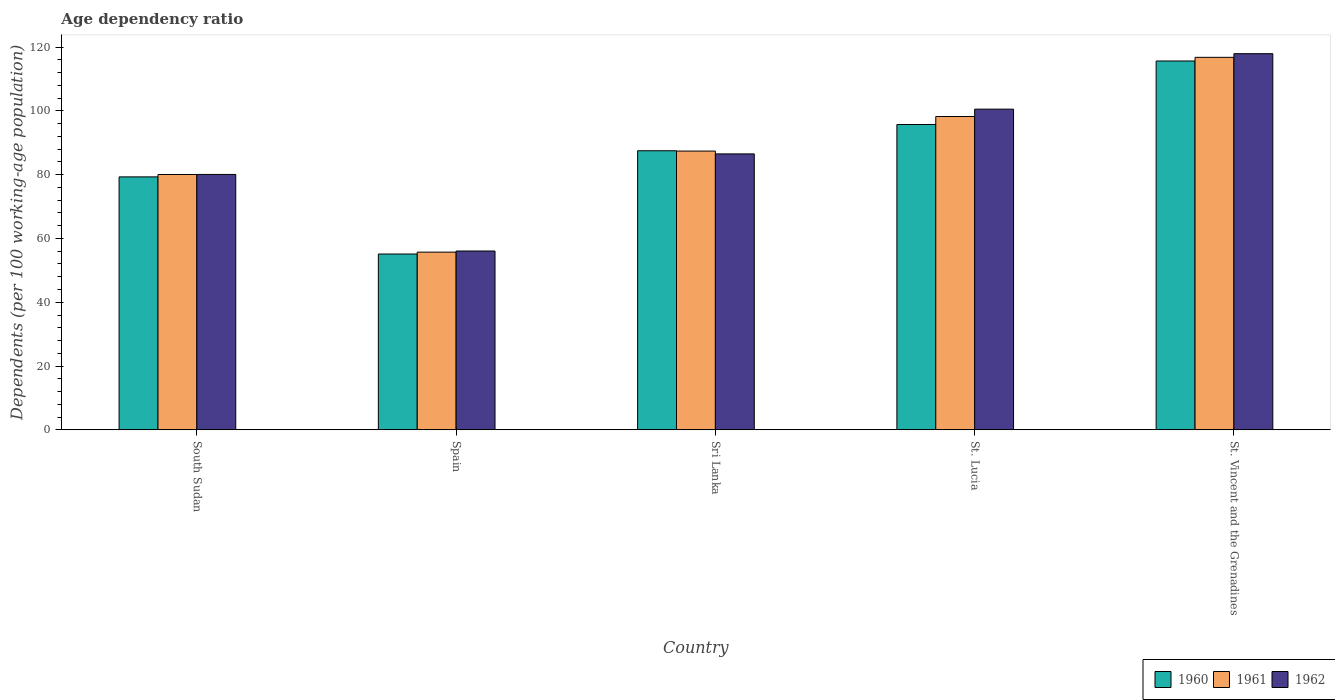How many groups of bars are there?
Keep it short and to the point. 5. Are the number of bars per tick equal to the number of legend labels?
Offer a terse response. Yes. Are the number of bars on each tick of the X-axis equal?
Make the answer very short. Yes. How many bars are there on the 4th tick from the left?
Provide a succinct answer. 3. What is the label of the 4th group of bars from the left?
Keep it short and to the point. St. Lucia. In how many cases, is the number of bars for a given country not equal to the number of legend labels?
Provide a succinct answer. 0. What is the age dependency ratio in in 1960 in St. Vincent and the Grenadines?
Your answer should be compact. 115.67. Across all countries, what is the maximum age dependency ratio in in 1961?
Your response must be concise. 116.81. Across all countries, what is the minimum age dependency ratio in in 1962?
Your answer should be compact. 56.08. In which country was the age dependency ratio in in 1960 maximum?
Offer a terse response. St. Vincent and the Grenadines. What is the total age dependency ratio in in 1962 in the graph?
Offer a very short reply. 441.21. What is the difference between the age dependency ratio in in 1960 in Sri Lanka and that in St. Lucia?
Offer a very short reply. -8.23. What is the difference between the age dependency ratio in in 1962 in South Sudan and the age dependency ratio in in 1961 in St. Vincent and the Grenadines?
Give a very brief answer. -36.73. What is the average age dependency ratio in in 1960 per country?
Keep it short and to the point. 86.68. What is the difference between the age dependency ratio in of/in 1962 and age dependency ratio in of/in 1961 in South Sudan?
Your answer should be very brief. 0.02. In how many countries, is the age dependency ratio in in 1962 greater than 112 %?
Offer a terse response. 1. What is the ratio of the age dependency ratio in in 1962 in Spain to that in Sri Lanka?
Your answer should be compact. 0.65. Is the age dependency ratio in in 1961 in Sri Lanka less than that in St. Lucia?
Keep it short and to the point. Yes. What is the difference between the highest and the second highest age dependency ratio in in 1960?
Your answer should be very brief. 28.15. What is the difference between the highest and the lowest age dependency ratio in in 1962?
Make the answer very short. 61.88. In how many countries, is the age dependency ratio in in 1962 greater than the average age dependency ratio in in 1962 taken over all countries?
Your response must be concise. 2. Is it the case that in every country, the sum of the age dependency ratio in in 1962 and age dependency ratio in in 1961 is greater than the age dependency ratio in in 1960?
Your answer should be very brief. Yes. How many countries are there in the graph?
Your answer should be compact. 5. Does the graph contain any zero values?
Provide a short and direct response. No. Does the graph contain grids?
Give a very brief answer. No. Where does the legend appear in the graph?
Your answer should be compact. Bottom right. What is the title of the graph?
Keep it short and to the point. Age dependency ratio. What is the label or title of the Y-axis?
Provide a succinct answer. Dependents (per 100 working-age population). What is the Dependents (per 100 working-age population) in 1960 in South Sudan?
Provide a short and direct response. 79.32. What is the Dependents (per 100 working-age population) of 1961 in South Sudan?
Your response must be concise. 80.07. What is the Dependents (per 100 working-age population) in 1962 in South Sudan?
Your response must be concise. 80.09. What is the Dependents (per 100 working-age population) of 1960 in Spain?
Give a very brief answer. 55.13. What is the Dependents (per 100 working-age population) of 1961 in Spain?
Offer a terse response. 55.72. What is the Dependents (per 100 working-age population) of 1962 in Spain?
Your answer should be very brief. 56.08. What is the Dependents (per 100 working-age population) in 1960 in Sri Lanka?
Give a very brief answer. 87.51. What is the Dependents (per 100 working-age population) in 1961 in Sri Lanka?
Provide a succinct answer. 87.42. What is the Dependents (per 100 working-age population) of 1962 in Sri Lanka?
Provide a short and direct response. 86.53. What is the Dependents (per 100 working-age population) in 1960 in St. Lucia?
Provide a short and direct response. 95.75. What is the Dependents (per 100 working-age population) of 1961 in St. Lucia?
Your response must be concise. 98.26. What is the Dependents (per 100 working-age population) of 1962 in St. Lucia?
Your answer should be very brief. 100.56. What is the Dependents (per 100 working-age population) of 1960 in St. Vincent and the Grenadines?
Provide a succinct answer. 115.67. What is the Dependents (per 100 working-age population) in 1961 in St. Vincent and the Grenadines?
Offer a terse response. 116.81. What is the Dependents (per 100 working-age population) of 1962 in St. Vincent and the Grenadines?
Give a very brief answer. 117.96. Across all countries, what is the maximum Dependents (per 100 working-age population) in 1960?
Give a very brief answer. 115.67. Across all countries, what is the maximum Dependents (per 100 working-age population) in 1961?
Your response must be concise. 116.81. Across all countries, what is the maximum Dependents (per 100 working-age population) of 1962?
Ensure brevity in your answer.  117.96. Across all countries, what is the minimum Dependents (per 100 working-age population) of 1960?
Your answer should be very brief. 55.13. Across all countries, what is the minimum Dependents (per 100 working-age population) of 1961?
Give a very brief answer. 55.72. Across all countries, what is the minimum Dependents (per 100 working-age population) of 1962?
Provide a short and direct response. 56.08. What is the total Dependents (per 100 working-age population) in 1960 in the graph?
Provide a succinct answer. 433.38. What is the total Dependents (per 100 working-age population) in 1961 in the graph?
Offer a very short reply. 438.28. What is the total Dependents (per 100 working-age population) in 1962 in the graph?
Your response must be concise. 441.21. What is the difference between the Dependents (per 100 working-age population) of 1960 in South Sudan and that in Spain?
Offer a terse response. 24.19. What is the difference between the Dependents (per 100 working-age population) in 1961 in South Sudan and that in Spain?
Offer a very short reply. 24.34. What is the difference between the Dependents (per 100 working-age population) of 1962 in South Sudan and that in Spain?
Keep it short and to the point. 24.01. What is the difference between the Dependents (per 100 working-age population) of 1960 in South Sudan and that in Sri Lanka?
Provide a short and direct response. -8.19. What is the difference between the Dependents (per 100 working-age population) in 1961 in South Sudan and that in Sri Lanka?
Provide a succinct answer. -7.35. What is the difference between the Dependents (per 100 working-age population) in 1962 in South Sudan and that in Sri Lanka?
Ensure brevity in your answer.  -6.44. What is the difference between the Dependents (per 100 working-age population) in 1960 in South Sudan and that in St. Lucia?
Your answer should be very brief. -16.42. What is the difference between the Dependents (per 100 working-age population) of 1961 in South Sudan and that in St. Lucia?
Provide a short and direct response. -18.19. What is the difference between the Dependents (per 100 working-age population) in 1962 in South Sudan and that in St. Lucia?
Your answer should be very brief. -20.47. What is the difference between the Dependents (per 100 working-age population) in 1960 in South Sudan and that in St. Vincent and the Grenadines?
Ensure brevity in your answer.  -36.34. What is the difference between the Dependents (per 100 working-age population) in 1961 in South Sudan and that in St. Vincent and the Grenadines?
Offer a very short reply. -36.75. What is the difference between the Dependents (per 100 working-age population) in 1962 in South Sudan and that in St. Vincent and the Grenadines?
Offer a terse response. -37.87. What is the difference between the Dependents (per 100 working-age population) in 1960 in Spain and that in Sri Lanka?
Ensure brevity in your answer.  -32.38. What is the difference between the Dependents (per 100 working-age population) in 1961 in Spain and that in Sri Lanka?
Your answer should be compact. -31.7. What is the difference between the Dependents (per 100 working-age population) in 1962 in Spain and that in Sri Lanka?
Offer a terse response. -30.45. What is the difference between the Dependents (per 100 working-age population) in 1960 in Spain and that in St. Lucia?
Provide a short and direct response. -40.62. What is the difference between the Dependents (per 100 working-age population) in 1961 in Spain and that in St. Lucia?
Offer a very short reply. -42.54. What is the difference between the Dependents (per 100 working-age population) of 1962 in Spain and that in St. Lucia?
Your response must be concise. -44.49. What is the difference between the Dependents (per 100 working-age population) of 1960 in Spain and that in St. Vincent and the Grenadines?
Keep it short and to the point. -60.53. What is the difference between the Dependents (per 100 working-age population) of 1961 in Spain and that in St. Vincent and the Grenadines?
Your response must be concise. -61.09. What is the difference between the Dependents (per 100 working-age population) in 1962 in Spain and that in St. Vincent and the Grenadines?
Offer a very short reply. -61.88. What is the difference between the Dependents (per 100 working-age population) in 1960 in Sri Lanka and that in St. Lucia?
Your response must be concise. -8.23. What is the difference between the Dependents (per 100 working-age population) in 1961 in Sri Lanka and that in St. Lucia?
Your response must be concise. -10.84. What is the difference between the Dependents (per 100 working-age population) in 1962 in Sri Lanka and that in St. Lucia?
Your answer should be compact. -14.03. What is the difference between the Dependents (per 100 working-age population) of 1960 in Sri Lanka and that in St. Vincent and the Grenadines?
Your answer should be very brief. -28.15. What is the difference between the Dependents (per 100 working-age population) of 1961 in Sri Lanka and that in St. Vincent and the Grenadines?
Ensure brevity in your answer.  -29.39. What is the difference between the Dependents (per 100 working-age population) of 1962 in Sri Lanka and that in St. Vincent and the Grenadines?
Make the answer very short. -31.43. What is the difference between the Dependents (per 100 working-age population) in 1960 in St. Lucia and that in St. Vincent and the Grenadines?
Provide a succinct answer. -19.92. What is the difference between the Dependents (per 100 working-age population) of 1961 in St. Lucia and that in St. Vincent and the Grenadines?
Offer a very short reply. -18.56. What is the difference between the Dependents (per 100 working-age population) in 1962 in St. Lucia and that in St. Vincent and the Grenadines?
Your response must be concise. -17.4. What is the difference between the Dependents (per 100 working-age population) in 1960 in South Sudan and the Dependents (per 100 working-age population) in 1961 in Spain?
Offer a very short reply. 23.6. What is the difference between the Dependents (per 100 working-age population) in 1960 in South Sudan and the Dependents (per 100 working-age population) in 1962 in Spain?
Your answer should be compact. 23.25. What is the difference between the Dependents (per 100 working-age population) in 1961 in South Sudan and the Dependents (per 100 working-age population) in 1962 in Spain?
Provide a short and direct response. 23.99. What is the difference between the Dependents (per 100 working-age population) of 1960 in South Sudan and the Dependents (per 100 working-age population) of 1961 in Sri Lanka?
Make the answer very short. -8.1. What is the difference between the Dependents (per 100 working-age population) in 1960 in South Sudan and the Dependents (per 100 working-age population) in 1962 in Sri Lanka?
Offer a very short reply. -7.21. What is the difference between the Dependents (per 100 working-age population) in 1961 in South Sudan and the Dependents (per 100 working-age population) in 1962 in Sri Lanka?
Provide a succinct answer. -6.46. What is the difference between the Dependents (per 100 working-age population) of 1960 in South Sudan and the Dependents (per 100 working-age population) of 1961 in St. Lucia?
Keep it short and to the point. -18.93. What is the difference between the Dependents (per 100 working-age population) in 1960 in South Sudan and the Dependents (per 100 working-age population) in 1962 in St. Lucia?
Offer a terse response. -21.24. What is the difference between the Dependents (per 100 working-age population) in 1961 in South Sudan and the Dependents (per 100 working-age population) in 1962 in St. Lucia?
Give a very brief answer. -20.5. What is the difference between the Dependents (per 100 working-age population) in 1960 in South Sudan and the Dependents (per 100 working-age population) in 1961 in St. Vincent and the Grenadines?
Ensure brevity in your answer.  -37.49. What is the difference between the Dependents (per 100 working-age population) in 1960 in South Sudan and the Dependents (per 100 working-age population) in 1962 in St. Vincent and the Grenadines?
Make the answer very short. -38.64. What is the difference between the Dependents (per 100 working-age population) in 1961 in South Sudan and the Dependents (per 100 working-age population) in 1962 in St. Vincent and the Grenadines?
Your response must be concise. -37.89. What is the difference between the Dependents (per 100 working-age population) of 1960 in Spain and the Dependents (per 100 working-age population) of 1961 in Sri Lanka?
Give a very brief answer. -32.29. What is the difference between the Dependents (per 100 working-age population) in 1960 in Spain and the Dependents (per 100 working-age population) in 1962 in Sri Lanka?
Ensure brevity in your answer.  -31.4. What is the difference between the Dependents (per 100 working-age population) of 1961 in Spain and the Dependents (per 100 working-age population) of 1962 in Sri Lanka?
Provide a succinct answer. -30.81. What is the difference between the Dependents (per 100 working-age population) in 1960 in Spain and the Dependents (per 100 working-age population) in 1961 in St. Lucia?
Give a very brief answer. -43.13. What is the difference between the Dependents (per 100 working-age population) in 1960 in Spain and the Dependents (per 100 working-age population) in 1962 in St. Lucia?
Your answer should be compact. -45.43. What is the difference between the Dependents (per 100 working-age population) in 1961 in Spain and the Dependents (per 100 working-age population) in 1962 in St. Lucia?
Offer a very short reply. -44.84. What is the difference between the Dependents (per 100 working-age population) in 1960 in Spain and the Dependents (per 100 working-age population) in 1961 in St. Vincent and the Grenadines?
Give a very brief answer. -61.68. What is the difference between the Dependents (per 100 working-age population) of 1960 in Spain and the Dependents (per 100 working-age population) of 1962 in St. Vincent and the Grenadines?
Keep it short and to the point. -62.83. What is the difference between the Dependents (per 100 working-age population) in 1961 in Spain and the Dependents (per 100 working-age population) in 1962 in St. Vincent and the Grenadines?
Make the answer very short. -62.24. What is the difference between the Dependents (per 100 working-age population) in 1960 in Sri Lanka and the Dependents (per 100 working-age population) in 1961 in St. Lucia?
Your answer should be compact. -10.74. What is the difference between the Dependents (per 100 working-age population) in 1960 in Sri Lanka and the Dependents (per 100 working-age population) in 1962 in St. Lucia?
Provide a succinct answer. -13.05. What is the difference between the Dependents (per 100 working-age population) in 1961 in Sri Lanka and the Dependents (per 100 working-age population) in 1962 in St. Lucia?
Offer a very short reply. -13.14. What is the difference between the Dependents (per 100 working-age population) in 1960 in Sri Lanka and the Dependents (per 100 working-age population) in 1961 in St. Vincent and the Grenadines?
Provide a succinct answer. -29.3. What is the difference between the Dependents (per 100 working-age population) of 1960 in Sri Lanka and the Dependents (per 100 working-age population) of 1962 in St. Vincent and the Grenadines?
Offer a very short reply. -30.45. What is the difference between the Dependents (per 100 working-age population) of 1961 in Sri Lanka and the Dependents (per 100 working-age population) of 1962 in St. Vincent and the Grenadines?
Provide a short and direct response. -30.54. What is the difference between the Dependents (per 100 working-age population) of 1960 in St. Lucia and the Dependents (per 100 working-age population) of 1961 in St. Vincent and the Grenadines?
Offer a very short reply. -21.07. What is the difference between the Dependents (per 100 working-age population) in 1960 in St. Lucia and the Dependents (per 100 working-age population) in 1962 in St. Vincent and the Grenadines?
Your answer should be compact. -22.21. What is the difference between the Dependents (per 100 working-age population) in 1961 in St. Lucia and the Dependents (per 100 working-age population) in 1962 in St. Vincent and the Grenadines?
Give a very brief answer. -19.7. What is the average Dependents (per 100 working-age population) of 1960 per country?
Ensure brevity in your answer.  86.68. What is the average Dependents (per 100 working-age population) in 1961 per country?
Keep it short and to the point. 87.66. What is the average Dependents (per 100 working-age population) in 1962 per country?
Your response must be concise. 88.24. What is the difference between the Dependents (per 100 working-age population) of 1960 and Dependents (per 100 working-age population) of 1961 in South Sudan?
Your response must be concise. -0.74. What is the difference between the Dependents (per 100 working-age population) of 1960 and Dependents (per 100 working-age population) of 1962 in South Sudan?
Ensure brevity in your answer.  -0.76. What is the difference between the Dependents (per 100 working-age population) of 1961 and Dependents (per 100 working-age population) of 1962 in South Sudan?
Give a very brief answer. -0.02. What is the difference between the Dependents (per 100 working-age population) of 1960 and Dependents (per 100 working-age population) of 1961 in Spain?
Offer a terse response. -0.59. What is the difference between the Dependents (per 100 working-age population) in 1960 and Dependents (per 100 working-age population) in 1962 in Spain?
Give a very brief answer. -0.94. What is the difference between the Dependents (per 100 working-age population) in 1961 and Dependents (per 100 working-age population) in 1962 in Spain?
Give a very brief answer. -0.35. What is the difference between the Dependents (per 100 working-age population) in 1960 and Dependents (per 100 working-age population) in 1961 in Sri Lanka?
Offer a very short reply. 0.09. What is the difference between the Dependents (per 100 working-age population) of 1960 and Dependents (per 100 working-age population) of 1962 in Sri Lanka?
Keep it short and to the point. 0.98. What is the difference between the Dependents (per 100 working-age population) of 1961 and Dependents (per 100 working-age population) of 1962 in Sri Lanka?
Provide a short and direct response. 0.89. What is the difference between the Dependents (per 100 working-age population) in 1960 and Dependents (per 100 working-age population) in 1961 in St. Lucia?
Give a very brief answer. -2.51. What is the difference between the Dependents (per 100 working-age population) in 1960 and Dependents (per 100 working-age population) in 1962 in St. Lucia?
Your answer should be very brief. -4.81. What is the difference between the Dependents (per 100 working-age population) of 1961 and Dependents (per 100 working-age population) of 1962 in St. Lucia?
Give a very brief answer. -2.3. What is the difference between the Dependents (per 100 working-age population) in 1960 and Dependents (per 100 working-age population) in 1961 in St. Vincent and the Grenadines?
Your response must be concise. -1.15. What is the difference between the Dependents (per 100 working-age population) in 1960 and Dependents (per 100 working-age population) in 1962 in St. Vincent and the Grenadines?
Provide a succinct answer. -2.29. What is the difference between the Dependents (per 100 working-age population) of 1961 and Dependents (per 100 working-age population) of 1962 in St. Vincent and the Grenadines?
Keep it short and to the point. -1.15. What is the ratio of the Dependents (per 100 working-age population) of 1960 in South Sudan to that in Spain?
Offer a very short reply. 1.44. What is the ratio of the Dependents (per 100 working-age population) in 1961 in South Sudan to that in Spain?
Offer a very short reply. 1.44. What is the ratio of the Dependents (per 100 working-age population) in 1962 in South Sudan to that in Spain?
Your response must be concise. 1.43. What is the ratio of the Dependents (per 100 working-age population) of 1960 in South Sudan to that in Sri Lanka?
Offer a very short reply. 0.91. What is the ratio of the Dependents (per 100 working-age population) of 1961 in South Sudan to that in Sri Lanka?
Make the answer very short. 0.92. What is the ratio of the Dependents (per 100 working-age population) in 1962 in South Sudan to that in Sri Lanka?
Keep it short and to the point. 0.93. What is the ratio of the Dependents (per 100 working-age population) of 1960 in South Sudan to that in St. Lucia?
Ensure brevity in your answer.  0.83. What is the ratio of the Dependents (per 100 working-age population) of 1961 in South Sudan to that in St. Lucia?
Offer a terse response. 0.81. What is the ratio of the Dependents (per 100 working-age population) in 1962 in South Sudan to that in St. Lucia?
Give a very brief answer. 0.8. What is the ratio of the Dependents (per 100 working-age population) in 1960 in South Sudan to that in St. Vincent and the Grenadines?
Your response must be concise. 0.69. What is the ratio of the Dependents (per 100 working-age population) in 1961 in South Sudan to that in St. Vincent and the Grenadines?
Keep it short and to the point. 0.69. What is the ratio of the Dependents (per 100 working-age population) in 1962 in South Sudan to that in St. Vincent and the Grenadines?
Your answer should be very brief. 0.68. What is the ratio of the Dependents (per 100 working-age population) in 1960 in Spain to that in Sri Lanka?
Offer a very short reply. 0.63. What is the ratio of the Dependents (per 100 working-age population) of 1961 in Spain to that in Sri Lanka?
Offer a terse response. 0.64. What is the ratio of the Dependents (per 100 working-age population) of 1962 in Spain to that in Sri Lanka?
Keep it short and to the point. 0.65. What is the ratio of the Dependents (per 100 working-age population) in 1960 in Spain to that in St. Lucia?
Give a very brief answer. 0.58. What is the ratio of the Dependents (per 100 working-age population) of 1961 in Spain to that in St. Lucia?
Make the answer very short. 0.57. What is the ratio of the Dependents (per 100 working-age population) of 1962 in Spain to that in St. Lucia?
Keep it short and to the point. 0.56. What is the ratio of the Dependents (per 100 working-age population) of 1960 in Spain to that in St. Vincent and the Grenadines?
Your answer should be very brief. 0.48. What is the ratio of the Dependents (per 100 working-age population) of 1961 in Spain to that in St. Vincent and the Grenadines?
Give a very brief answer. 0.48. What is the ratio of the Dependents (per 100 working-age population) in 1962 in Spain to that in St. Vincent and the Grenadines?
Your answer should be very brief. 0.48. What is the ratio of the Dependents (per 100 working-age population) of 1960 in Sri Lanka to that in St. Lucia?
Your answer should be compact. 0.91. What is the ratio of the Dependents (per 100 working-age population) in 1961 in Sri Lanka to that in St. Lucia?
Offer a terse response. 0.89. What is the ratio of the Dependents (per 100 working-age population) of 1962 in Sri Lanka to that in St. Lucia?
Your answer should be very brief. 0.86. What is the ratio of the Dependents (per 100 working-age population) in 1960 in Sri Lanka to that in St. Vincent and the Grenadines?
Keep it short and to the point. 0.76. What is the ratio of the Dependents (per 100 working-age population) in 1961 in Sri Lanka to that in St. Vincent and the Grenadines?
Your response must be concise. 0.75. What is the ratio of the Dependents (per 100 working-age population) of 1962 in Sri Lanka to that in St. Vincent and the Grenadines?
Your answer should be compact. 0.73. What is the ratio of the Dependents (per 100 working-age population) in 1960 in St. Lucia to that in St. Vincent and the Grenadines?
Give a very brief answer. 0.83. What is the ratio of the Dependents (per 100 working-age population) in 1961 in St. Lucia to that in St. Vincent and the Grenadines?
Your answer should be very brief. 0.84. What is the ratio of the Dependents (per 100 working-age population) in 1962 in St. Lucia to that in St. Vincent and the Grenadines?
Ensure brevity in your answer.  0.85. What is the difference between the highest and the second highest Dependents (per 100 working-age population) of 1960?
Provide a succinct answer. 19.92. What is the difference between the highest and the second highest Dependents (per 100 working-age population) in 1961?
Make the answer very short. 18.56. What is the difference between the highest and the second highest Dependents (per 100 working-age population) in 1962?
Provide a short and direct response. 17.4. What is the difference between the highest and the lowest Dependents (per 100 working-age population) of 1960?
Your answer should be compact. 60.53. What is the difference between the highest and the lowest Dependents (per 100 working-age population) in 1961?
Ensure brevity in your answer.  61.09. What is the difference between the highest and the lowest Dependents (per 100 working-age population) in 1962?
Your answer should be compact. 61.88. 